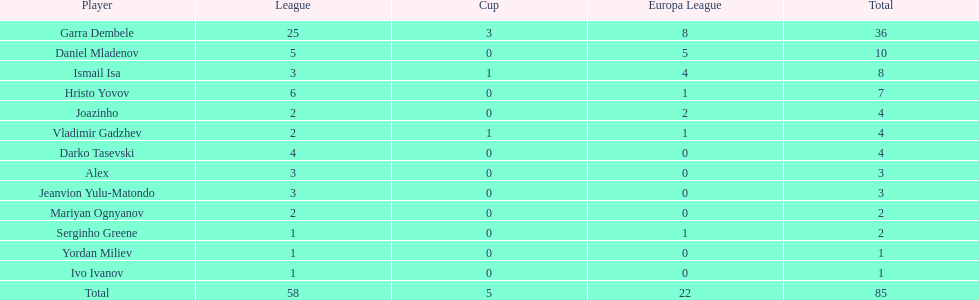What number of players in the cup didn't manage to score any goals? 10. 